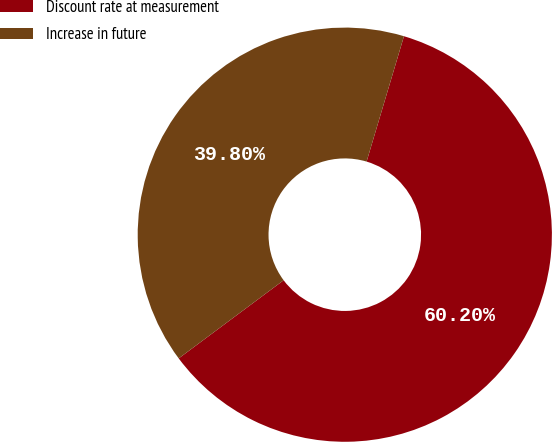Convert chart. <chart><loc_0><loc_0><loc_500><loc_500><pie_chart><fcel>Discount rate at measurement<fcel>Increase in future<nl><fcel>60.2%<fcel>39.8%<nl></chart> 